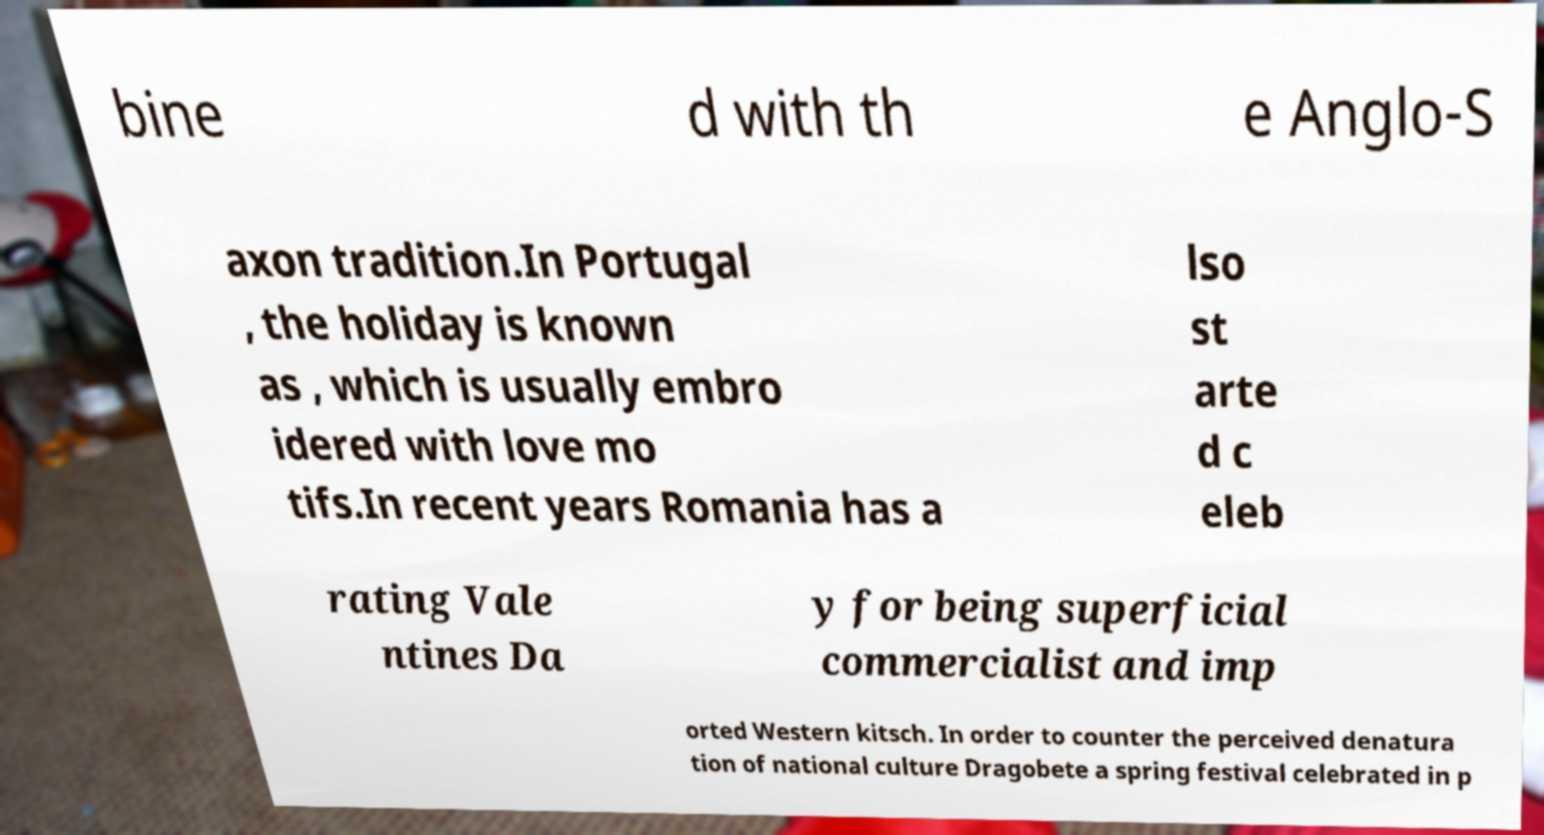Could you assist in decoding the text presented in this image and type it out clearly? bine d with th e Anglo-S axon tradition.In Portugal , the holiday is known as , which is usually embro idered with love mo tifs.In recent years Romania has a lso st arte d c eleb rating Vale ntines Da y for being superficial commercialist and imp orted Western kitsch. In order to counter the perceived denatura tion of national culture Dragobete a spring festival celebrated in p 